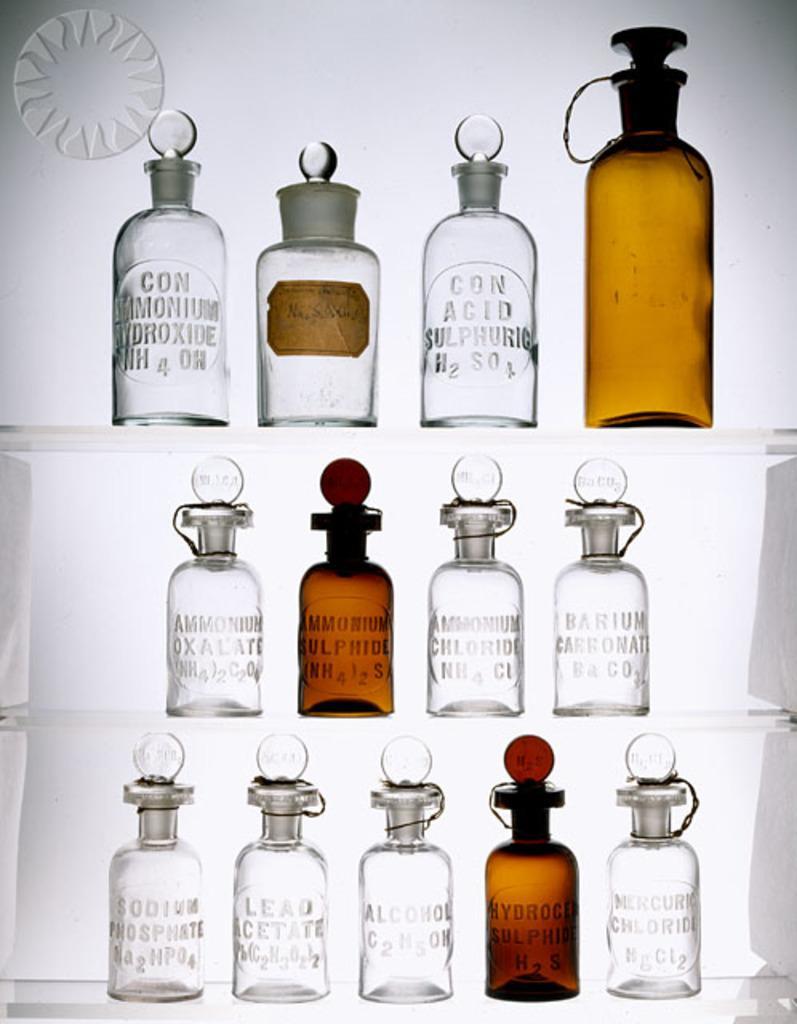Describe this image in one or two sentences. In a picture we can find some bottles and some liquid in that. In background we can find a white wall. 